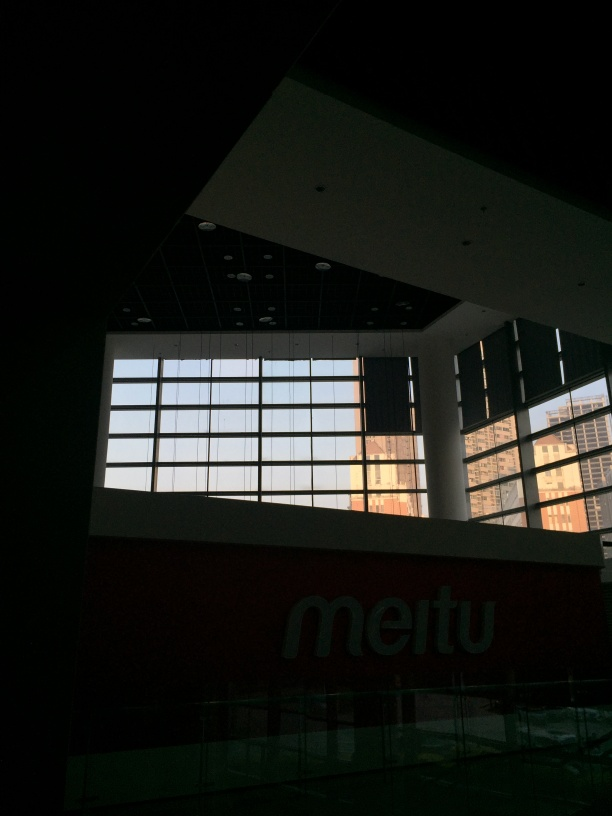Can you describe the lighting in this indoor scene? The lighting in the image creates a high contrast between the bright backlight coming from the windows and the darker interior. This dynamic suggests an early morning or late afternoon, given the long shadows and the warm hue that penetrates the space. The indoor lighting appears to be off, emphasizing the natural light's impact on the scene. 